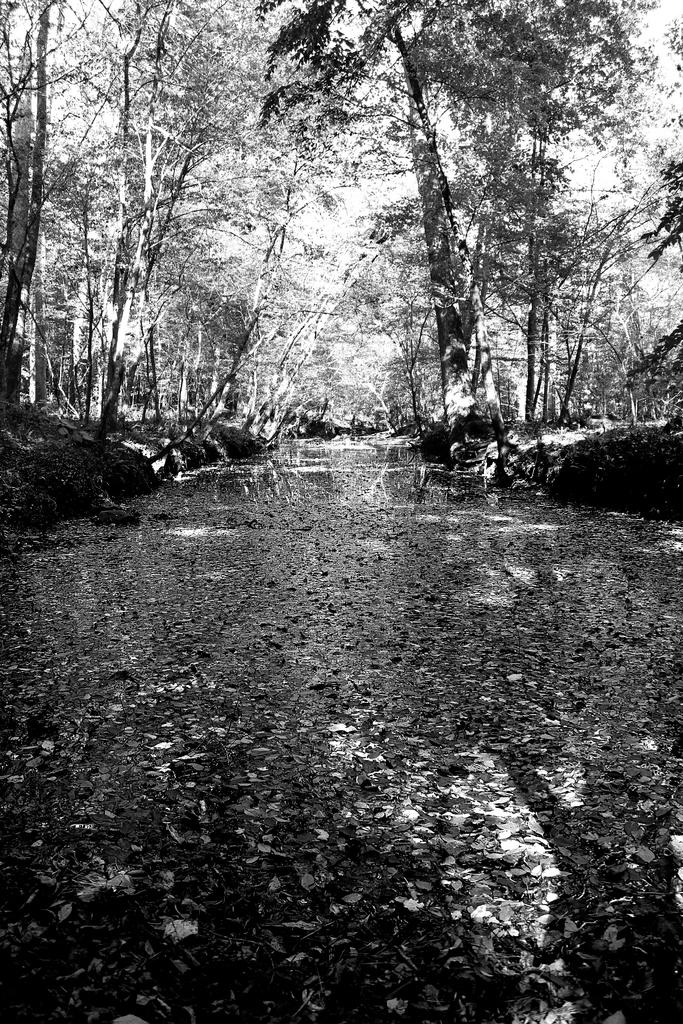What body of water is visible in the image? There is a lake in the image. What can be found floating in the lake? There are leaves in the lake. What type of vegetation is present in the image? There are trees and plants in the image. Where is the kitty playing in the image? There is no kitty present in the image. Can you see any cobwebs in the image? There is no mention of cobwebs in the provided facts, and they are not visible in the image. 